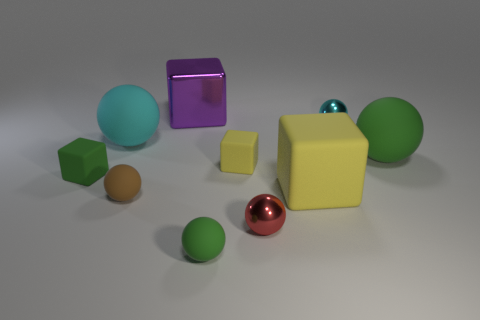Subtract all brown spheres. How many spheres are left? 5 Subtract all cyan matte balls. How many balls are left? 5 Subtract 1 blocks. How many blocks are left? 3 Subtract all brown cubes. Subtract all blue cylinders. How many cubes are left? 4 Subtract all cubes. How many objects are left? 6 Add 6 large green matte things. How many large green matte things are left? 7 Add 7 green balls. How many green balls exist? 9 Subtract 0 brown cubes. How many objects are left? 10 Subtract all small purple objects. Subtract all small brown spheres. How many objects are left? 9 